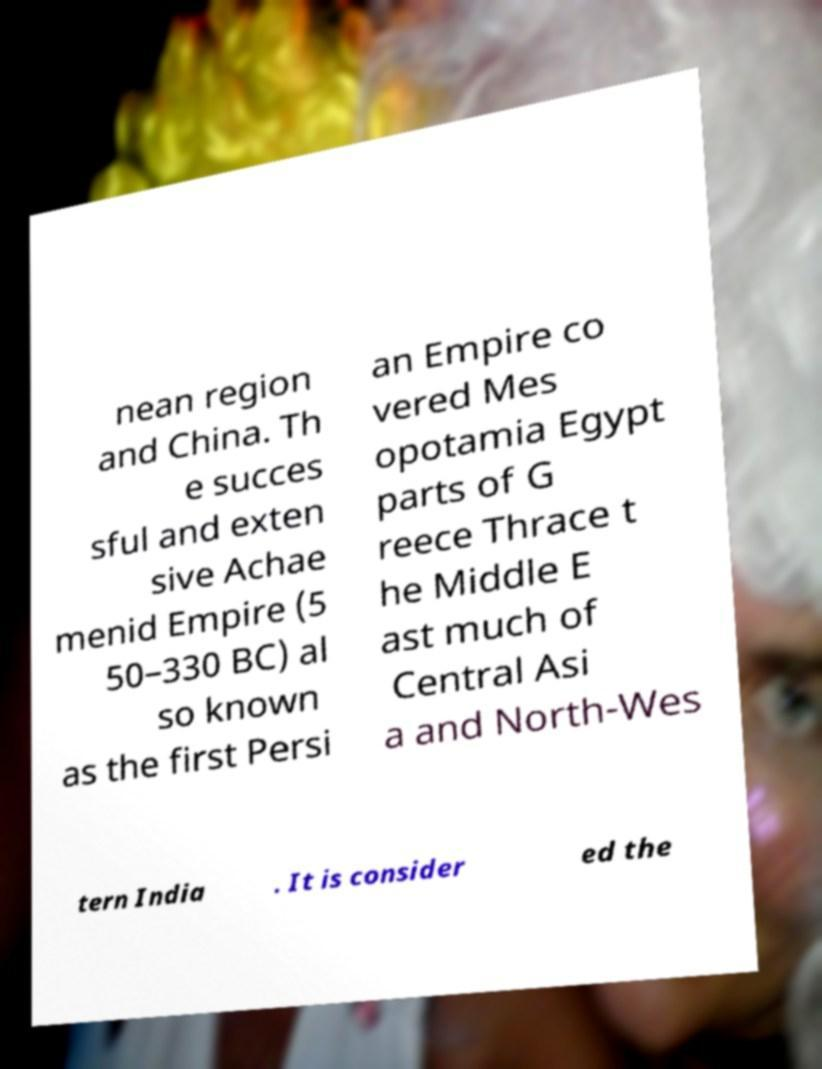Could you extract and type out the text from this image? nean region and China. Th e succes sful and exten sive Achae menid Empire (5 50–330 BC) al so known as the first Persi an Empire co vered Mes opotamia Egypt parts of G reece Thrace t he Middle E ast much of Central Asi a and North-Wes tern India . It is consider ed the 